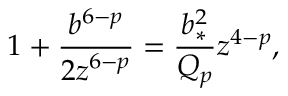Convert formula to latex. <formula><loc_0><loc_0><loc_500><loc_500>1 + { \frac { b ^ { 6 - p } } { 2 z ^ { 6 - p } } } = { \frac { b _ { * } ^ { 2 } } { Q _ { p } } } z ^ { 4 - p } ,</formula> 